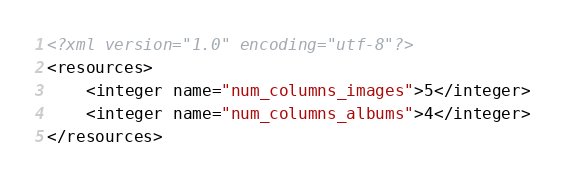Convert code to text. <code><loc_0><loc_0><loc_500><loc_500><_XML_><?xml version="1.0" encoding="utf-8"?>
<resources>
    <integer name="num_columns_images">5</integer>
    <integer name="num_columns_albums">4</integer>
</resources></code> 